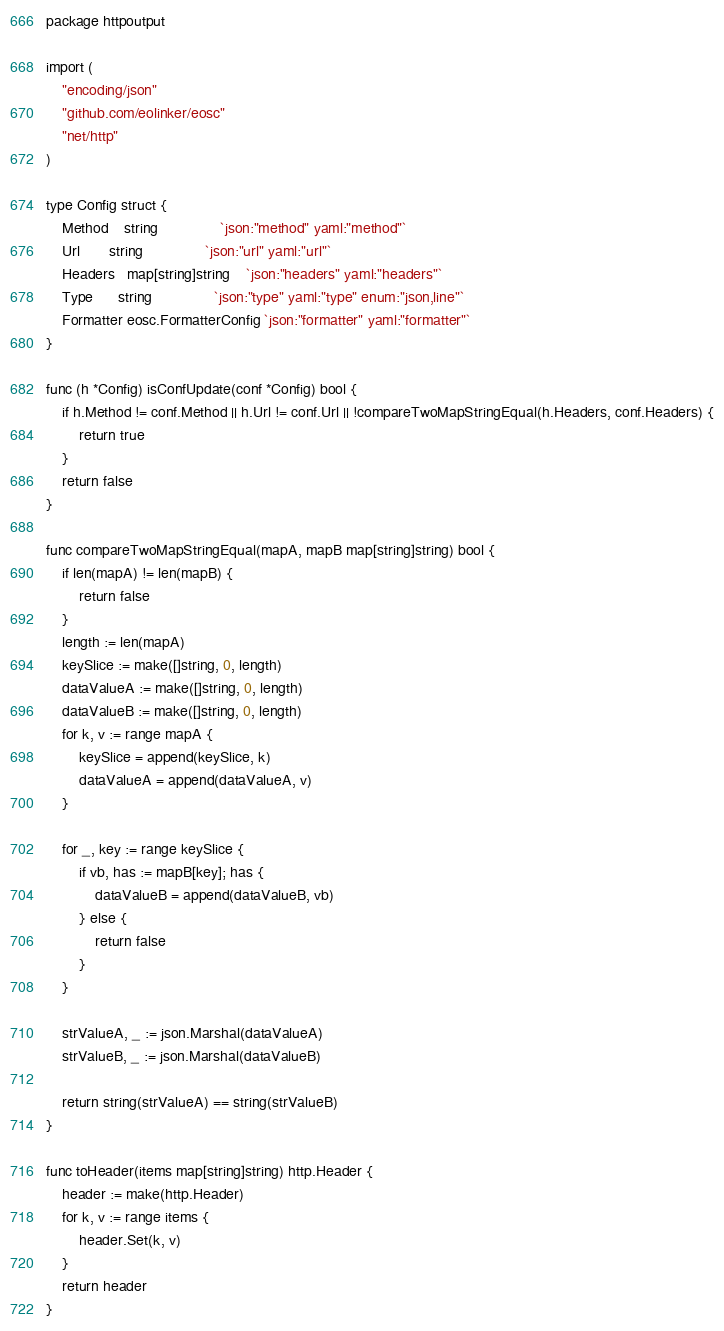Convert code to text. <code><loc_0><loc_0><loc_500><loc_500><_Go_>package httpoutput

import (
	"encoding/json"
	"github.com/eolinker/eosc"
	"net/http"
)

type Config struct {
	Method    string               `json:"method" yaml:"method"`
	Url       string               `json:"url" yaml:"url"`
	Headers   map[string]string    `json:"headers" yaml:"headers"`
	Type      string               `json:"type" yaml:"type" enum:"json,line"`
	Formatter eosc.FormatterConfig `json:"formatter" yaml:"formatter"`
}

func (h *Config) isConfUpdate(conf *Config) bool {
	if h.Method != conf.Method || h.Url != conf.Url || !compareTwoMapStringEqual(h.Headers, conf.Headers) {
		return true
	}
	return false
}

func compareTwoMapStringEqual(mapA, mapB map[string]string) bool {
	if len(mapA) != len(mapB) {
		return false
	}
	length := len(mapA)
	keySlice := make([]string, 0, length)
	dataValueA := make([]string, 0, length)
	dataValueB := make([]string, 0, length)
	for k, v := range mapA {
		keySlice = append(keySlice, k)
		dataValueA = append(dataValueA, v)
	}

	for _, key := range keySlice {
		if vb, has := mapB[key]; has {
			dataValueB = append(dataValueB, vb)
		} else {
			return false
		}
	}

	strValueA, _ := json.Marshal(dataValueA)
	strValueB, _ := json.Marshal(dataValueB)

	return string(strValueA) == string(strValueB)
}

func toHeader(items map[string]string) http.Header {
	header := make(http.Header)
	for k, v := range items {
		header.Set(k, v)
	}
	return header
}
</code> 